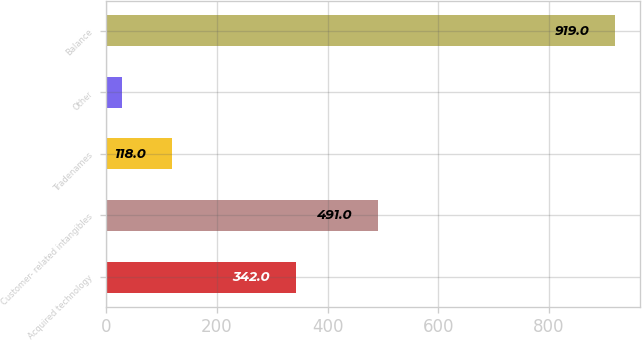<chart> <loc_0><loc_0><loc_500><loc_500><bar_chart><fcel>Acquired technology<fcel>Customer- related intangibles<fcel>Tradenames<fcel>Other<fcel>Balance<nl><fcel>342<fcel>491<fcel>118<fcel>29<fcel>919<nl></chart> 